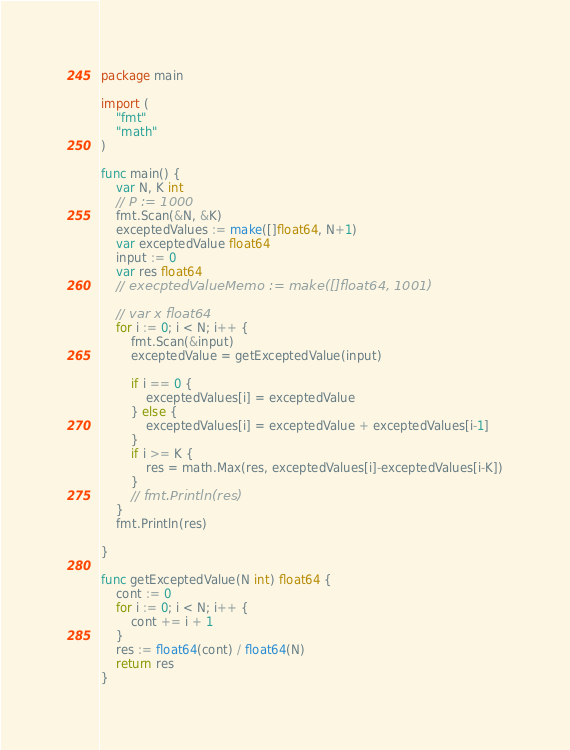<code> <loc_0><loc_0><loc_500><loc_500><_Go_>package main

import (
	"fmt"
	"math"
)

func main() {
	var N, K int
	// P := 1000
	fmt.Scan(&N, &K)
	exceptedValues := make([]float64, N+1)
	var exceptedValue float64
	input := 0
	var res float64
	// execptedValueMemo := make([]float64, 1001)

	// var x float64
	for i := 0; i < N; i++ {
		fmt.Scan(&input)
		exceptedValue = getExceptedValue(input)

		if i == 0 {
			exceptedValues[i] = exceptedValue
		} else {
			exceptedValues[i] = exceptedValue + exceptedValues[i-1]
		}
		if i >= K {
			res = math.Max(res, exceptedValues[i]-exceptedValues[i-K])
		}
		// fmt.Println(res)
	}
	fmt.Println(res)

}

func getExceptedValue(N int) float64 {
	cont := 0
	for i := 0; i < N; i++ {
		cont += i + 1
	}
	res := float64(cont) / float64(N)
	return res
}
</code> 